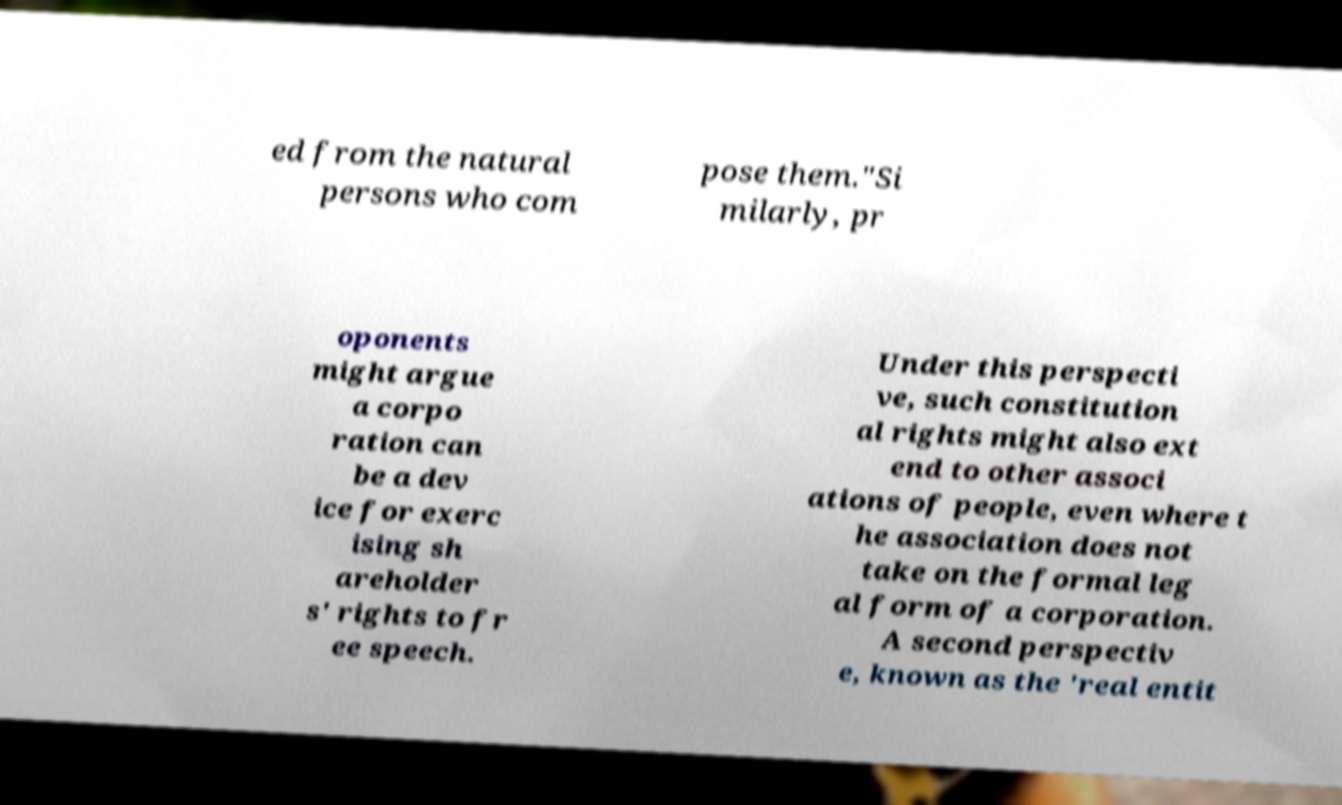Please identify and transcribe the text found in this image. ed from the natural persons who com pose them."Si milarly, pr oponents might argue a corpo ration can be a dev ice for exerc ising sh areholder s' rights to fr ee speech. Under this perspecti ve, such constitution al rights might also ext end to other associ ations of people, even where t he association does not take on the formal leg al form of a corporation. A second perspectiv e, known as the 'real entit 